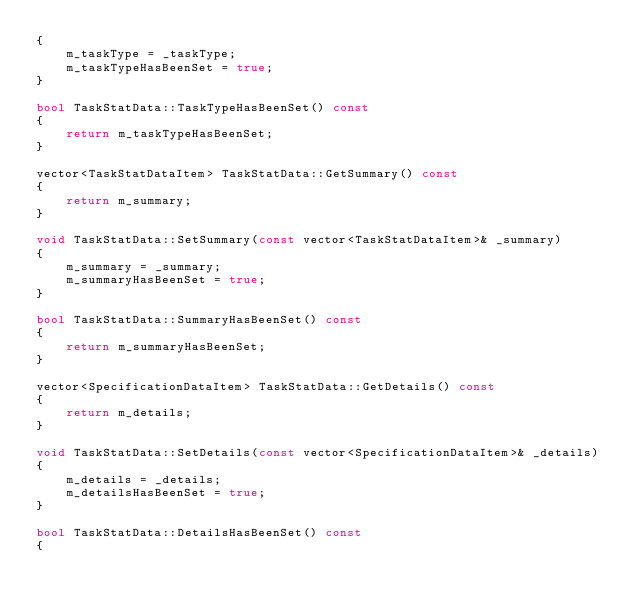Convert code to text. <code><loc_0><loc_0><loc_500><loc_500><_C++_>{
    m_taskType = _taskType;
    m_taskTypeHasBeenSet = true;
}

bool TaskStatData::TaskTypeHasBeenSet() const
{
    return m_taskTypeHasBeenSet;
}

vector<TaskStatDataItem> TaskStatData::GetSummary() const
{
    return m_summary;
}

void TaskStatData::SetSummary(const vector<TaskStatDataItem>& _summary)
{
    m_summary = _summary;
    m_summaryHasBeenSet = true;
}

bool TaskStatData::SummaryHasBeenSet() const
{
    return m_summaryHasBeenSet;
}

vector<SpecificationDataItem> TaskStatData::GetDetails() const
{
    return m_details;
}

void TaskStatData::SetDetails(const vector<SpecificationDataItem>& _details)
{
    m_details = _details;
    m_detailsHasBeenSet = true;
}

bool TaskStatData::DetailsHasBeenSet() const
{</code> 